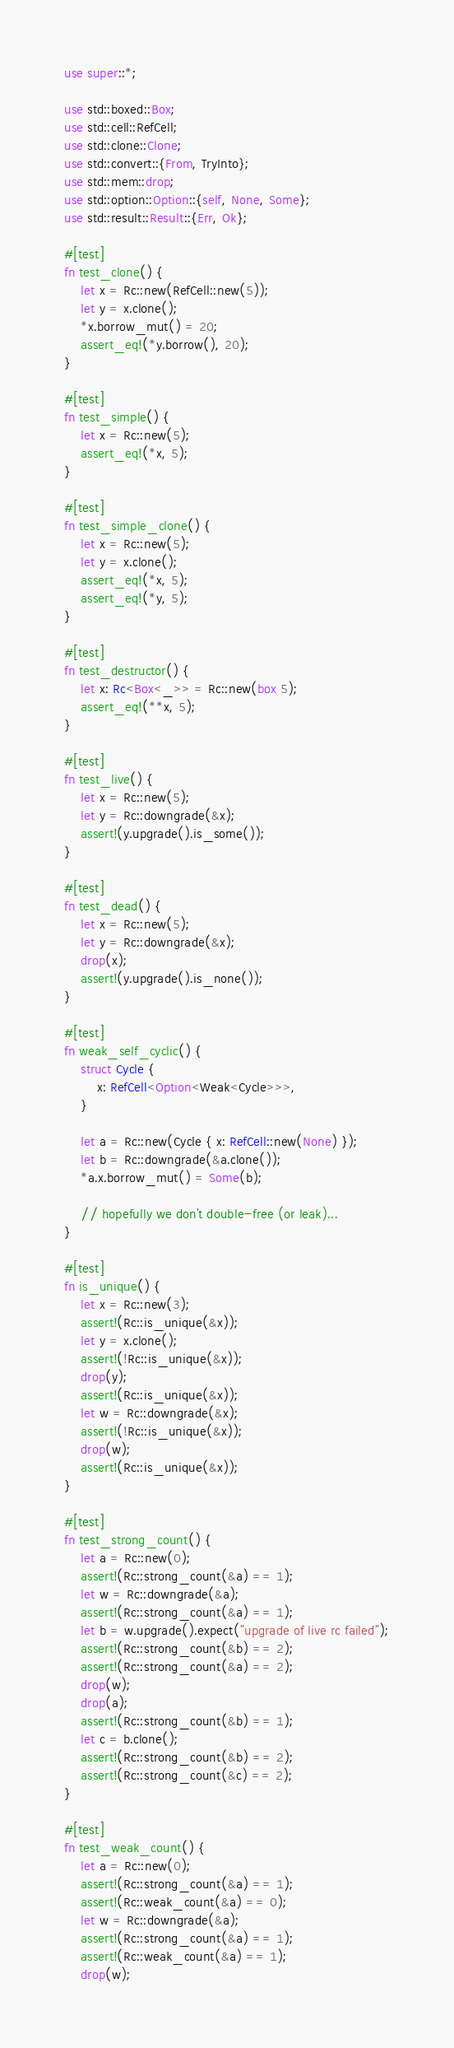Convert code to text. <code><loc_0><loc_0><loc_500><loc_500><_Rust_>use super::*;

use std::boxed::Box;
use std::cell::RefCell;
use std::clone::Clone;
use std::convert::{From, TryInto};
use std::mem::drop;
use std::option::Option::{self, None, Some};
use std::result::Result::{Err, Ok};

#[test]
fn test_clone() {
    let x = Rc::new(RefCell::new(5));
    let y = x.clone();
    *x.borrow_mut() = 20;
    assert_eq!(*y.borrow(), 20);
}

#[test]
fn test_simple() {
    let x = Rc::new(5);
    assert_eq!(*x, 5);
}

#[test]
fn test_simple_clone() {
    let x = Rc::new(5);
    let y = x.clone();
    assert_eq!(*x, 5);
    assert_eq!(*y, 5);
}

#[test]
fn test_destructor() {
    let x: Rc<Box<_>> = Rc::new(box 5);
    assert_eq!(**x, 5);
}

#[test]
fn test_live() {
    let x = Rc::new(5);
    let y = Rc::downgrade(&x);
    assert!(y.upgrade().is_some());
}

#[test]
fn test_dead() {
    let x = Rc::new(5);
    let y = Rc::downgrade(&x);
    drop(x);
    assert!(y.upgrade().is_none());
}

#[test]
fn weak_self_cyclic() {
    struct Cycle {
        x: RefCell<Option<Weak<Cycle>>>,
    }

    let a = Rc::new(Cycle { x: RefCell::new(None) });
    let b = Rc::downgrade(&a.clone());
    *a.x.borrow_mut() = Some(b);

    // hopefully we don't double-free (or leak)...
}

#[test]
fn is_unique() {
    let x = Rc::new(3);
    assert!(Rc::is_unique(&x));
    let y = x.clone();
    assert!(!Rc::is_unique(&x));
    drop(y);
    assert!(Rc::is_unique(&x));
    let w = Rc::downgrade(&x);
    assert!(!Rc::is_unique(&x));
    drop(w);
    assert!(Rc::is_unique(&x));
}

#[test]
fn test_strong_count() {
    let a = Rc::new(0);
    assert!(Rc::strong_count(&a) == 1);
    let w = Rc::downgrade(&a);
    assert!(Rc::strong_count(&a) == 1);
    let b = w.upgrade().expect("upgrade of live rc failed");
    assert!(Rc::strong_count(&b) == 2);
    assert!(Rc::strong_count(&a) == 2);
    drop(w);
    drop(a);
    assert!(Rc::strong_count(&b) == 1);
    let c = b.clone();
    assert!(Rc::strong_count(&b) == 2);
    assert!(Rc::strong_count(&c) == 2);
}

#[test]
fn test_weak_count() {
    let a = Rc::new(0);
    assert!(Rc::strong_count(&a) == 1);
    assert!(Rc::weak_count(&a) == 0);
    let w = Rc::downgrade(&a);
    assert!(Rc::strong_count(&a) == 1);
    assert!(Rc::weak_count(&a) == 1);
    drop(w);</code> 